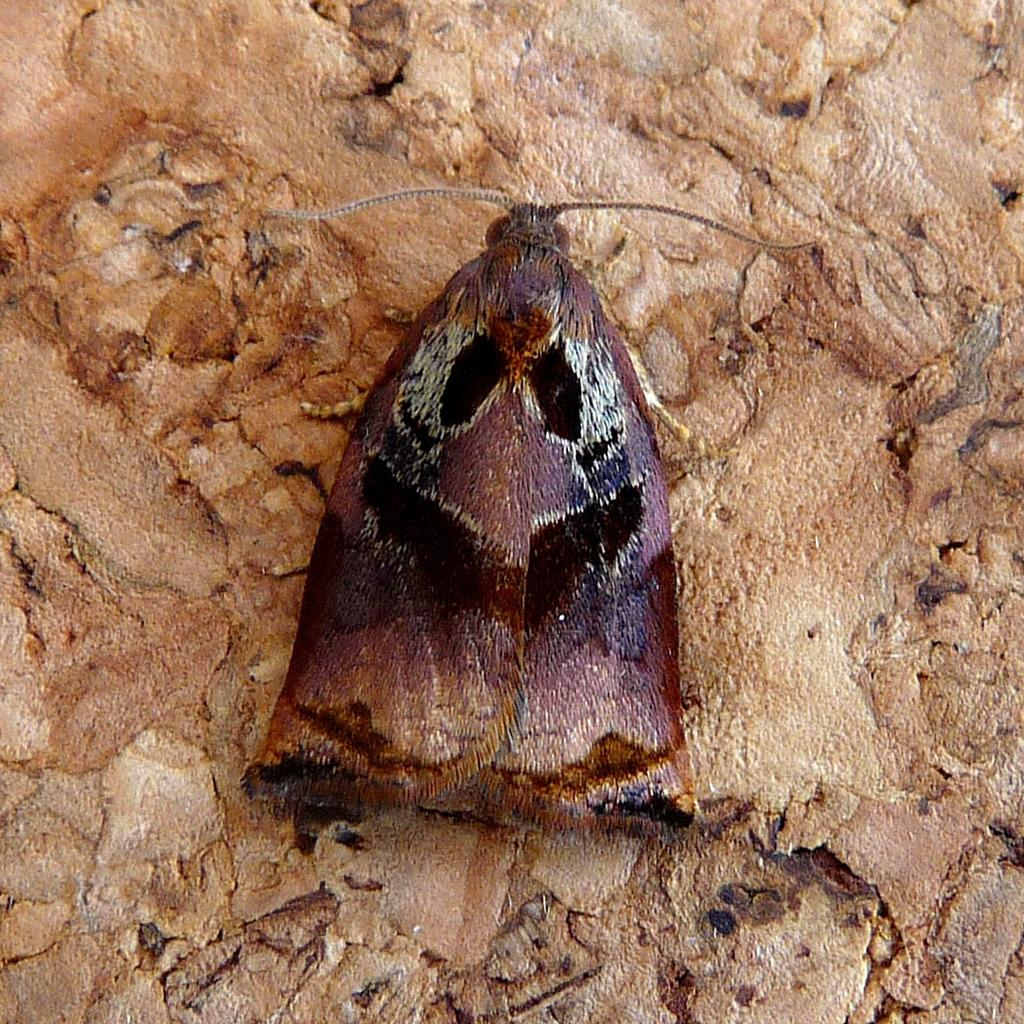What is the color of the surface in the image? The surface in the image is cream-colored. What can be seen on the surface? There is an insect on the surface. Can you describe the insect's appearance? The insect has a dark pink, brown, and black color. What type of cloud can be seen in the image? There is no cloud present in the image; it features a surface with an insect on it. How does the insect's presence affect the end of the story in the image? There is no story or narrative present in the image, so it is not possible to determine how the insect's presence affects the end. 